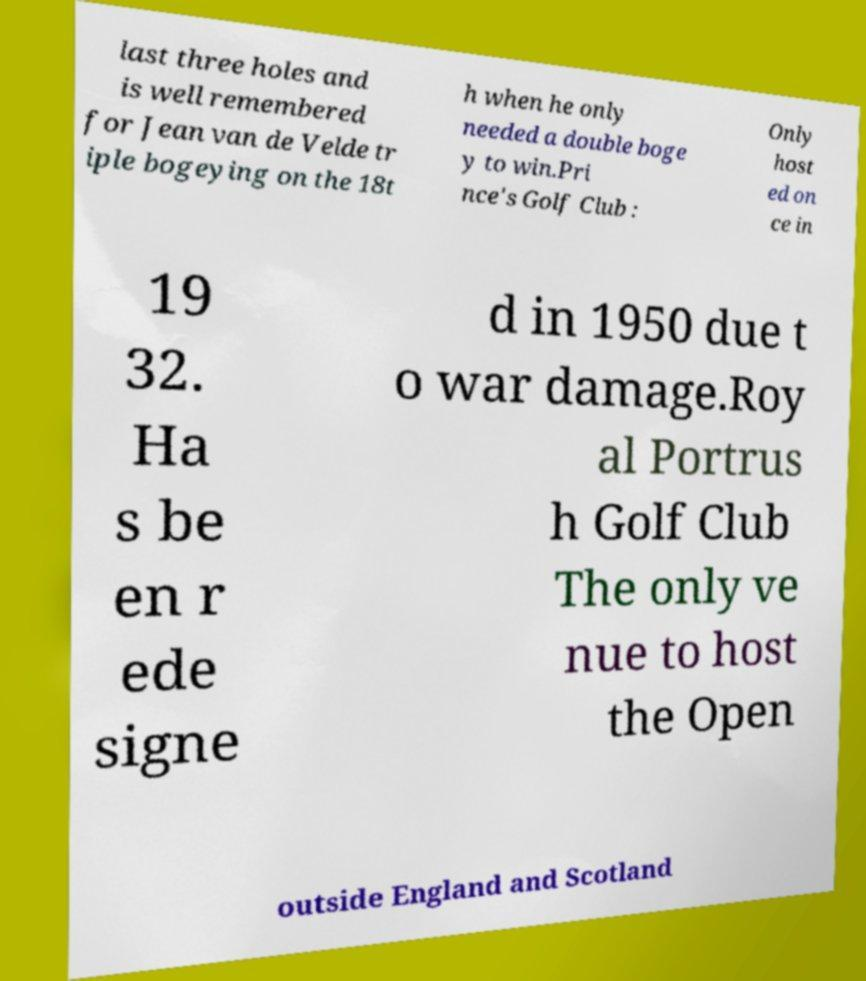Can you accurately transcribe the text from the provided image for me? last three holes and is well remembered for Jean van de Velde tr iple bogeying on the 18t h when he only needed a double boge y to win.Pri nce's Golf Club : Only host ed on ce in 19 32. Ha s be en r ede signe d in 1950 due t o war damage.Roy al Portrus h Golf Club The only ve nue to host the Open outside England and Scotland 